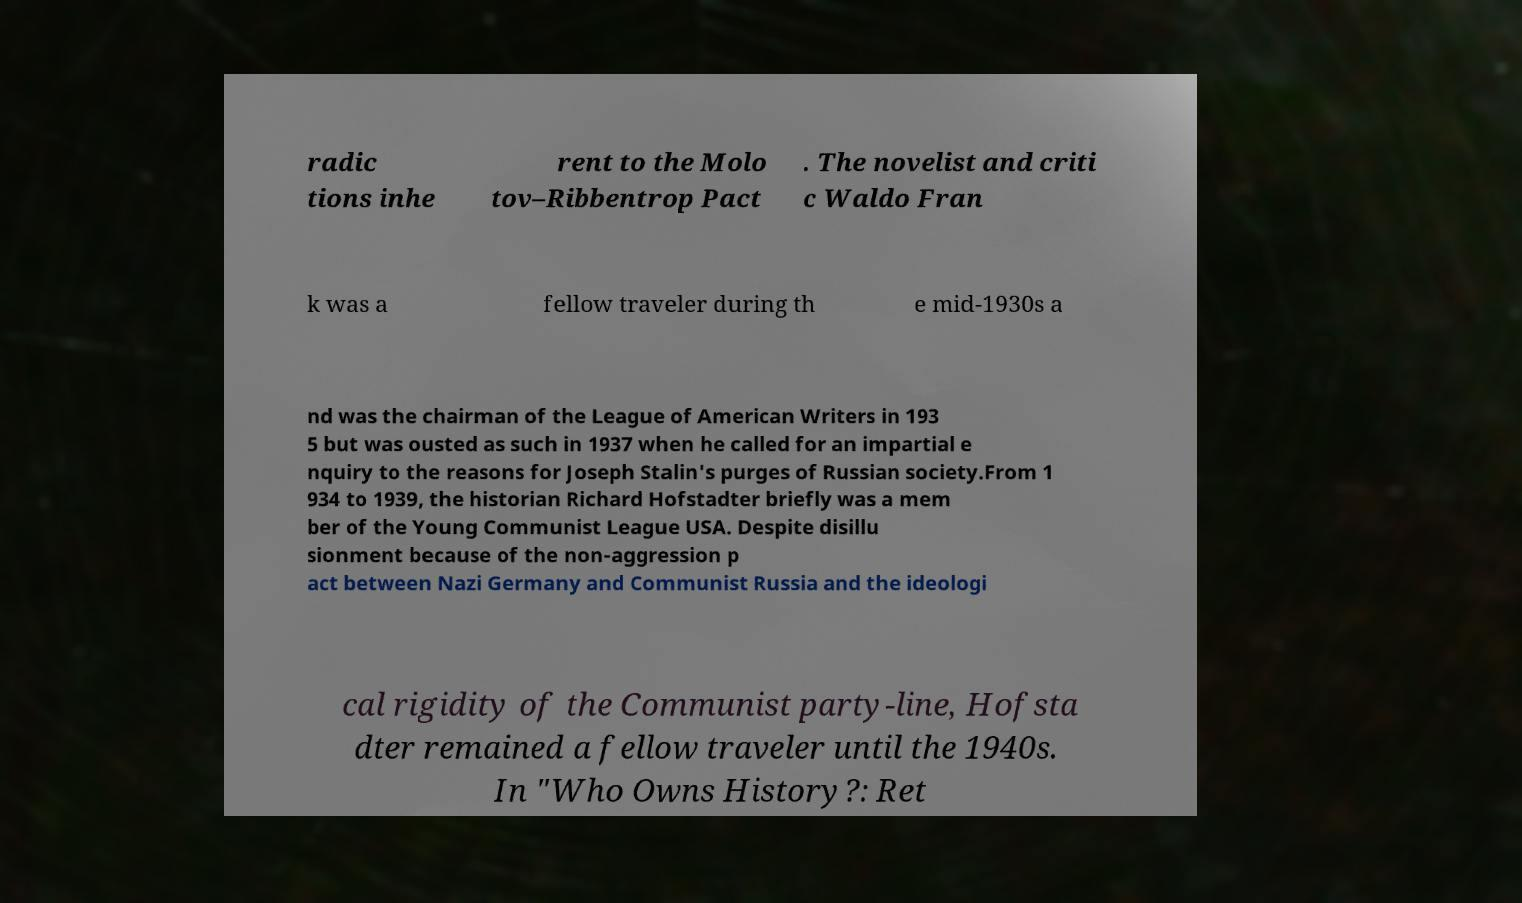I need the written content from this picture converted into text. Can you do that? radic tions inhe rent to the Molo tov–Ribbentrop Pact . The novelist and criti c Waldo Fran k was a fellow traveler during th e mid-1930s a nd was the chairman of the League of American Writers in 193 5 but was ousted as such in 1937 when he called for an impartial e nquiry to the reasons for Joseph Stalin's purges of Russian society.From 1 934 to 1939, the historian Richard Hofstadter briefly was a mem ber of the Young Communist League USA. Despite disillu sionment because of the non-aggression p act between Nazi Germany and Communist Russia and the ideologi cal rigidity of the Communist party-line, Hofsta dter remained a fellow traveler until the 1940s. In "Who Owns History?: Ret 